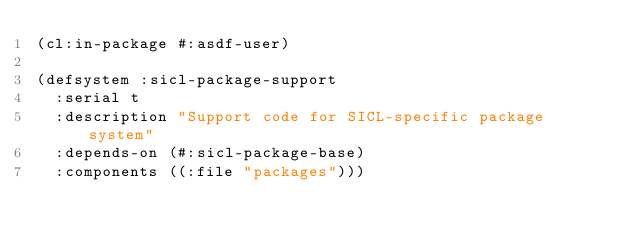<code> <loc_0><loc_0><loc_500><loc_500><_Lisp_>(cl:in-package #:asdf-user)

(defsystem :sicl-package-support
  :serial t
  :description "Support code for SICL-specific package system"
  :depends-on (#:sicl-package-base)
  :components ((:file "packages")))
</code> 